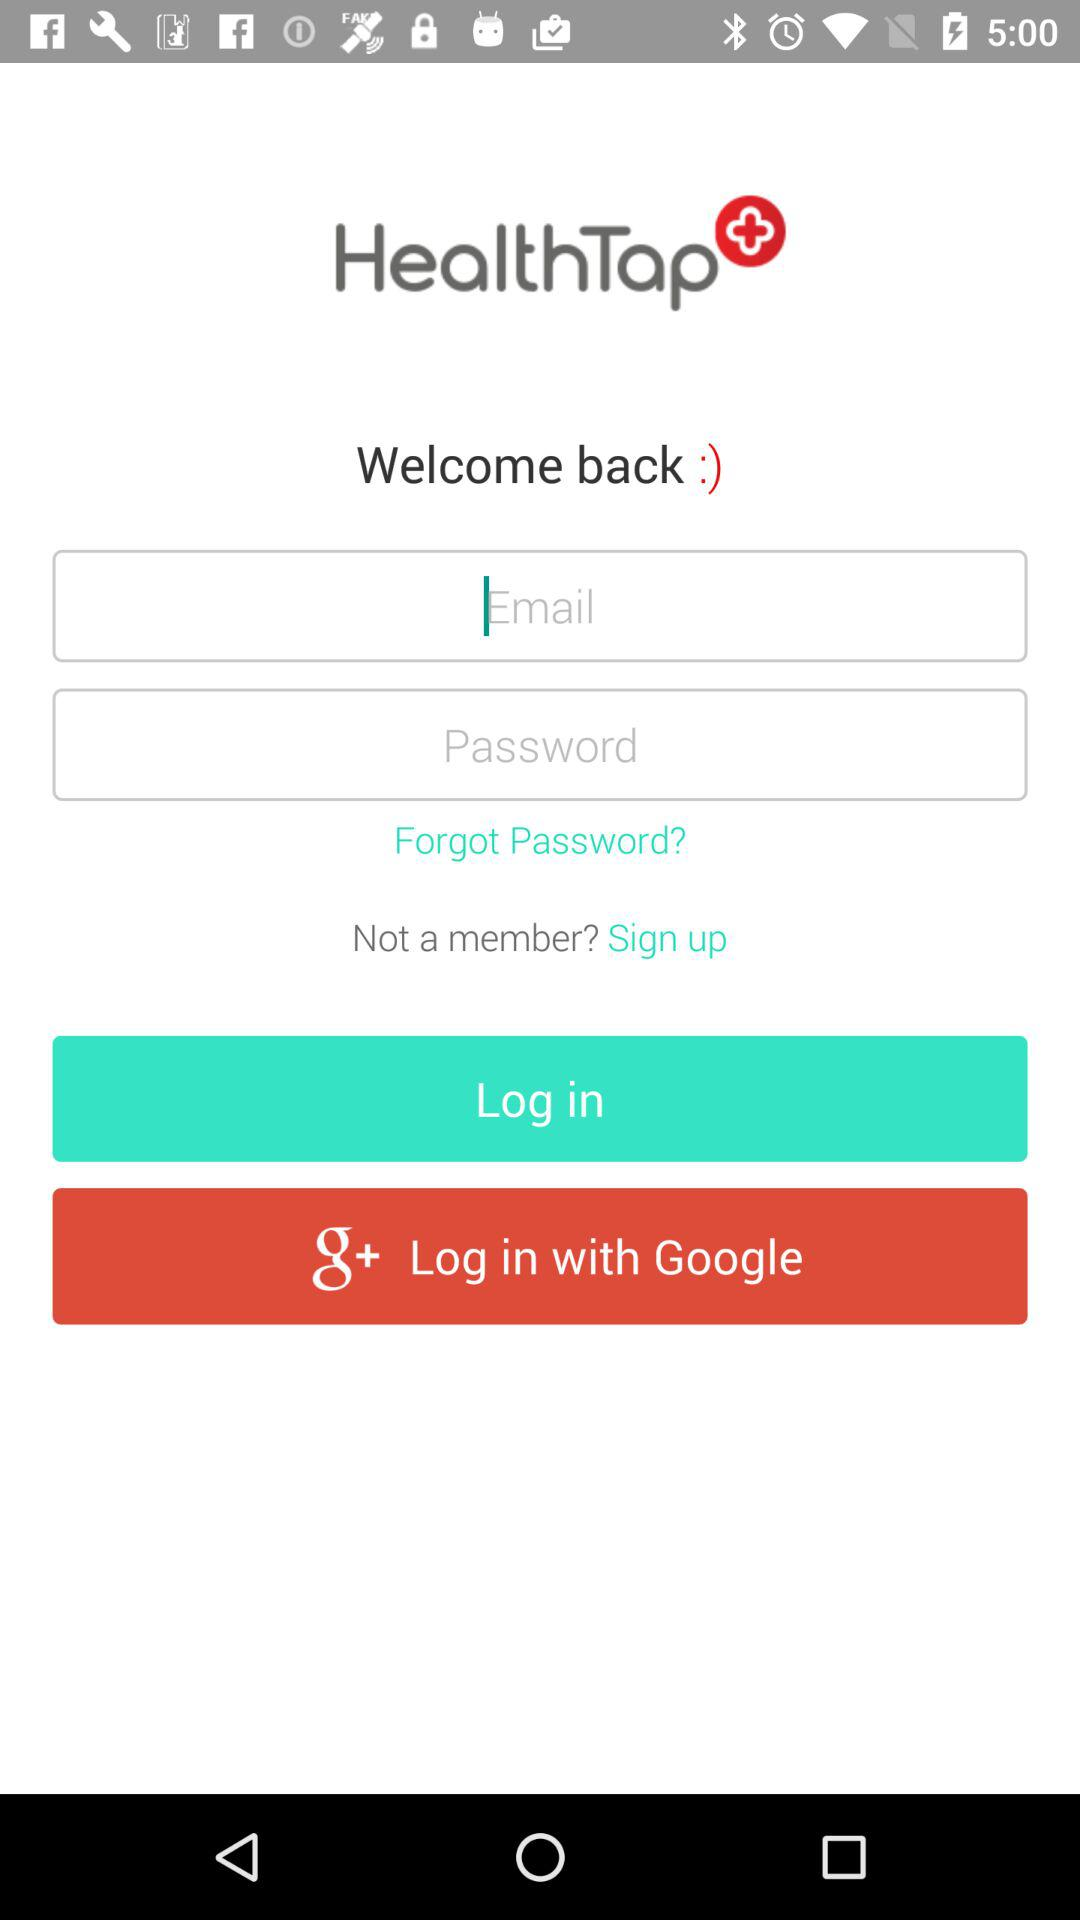Which email address is used for the account?
When the provided information is insufficient, respond with <no answer>. <no answer> 